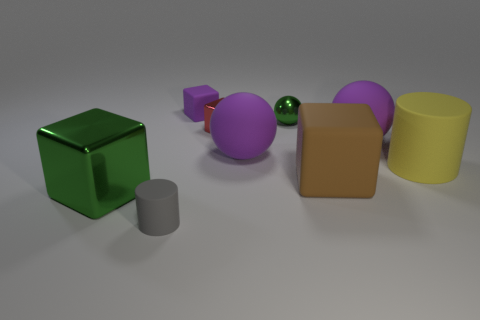What is the material of the block that is the same color as the tiny metal sphere?
Provide a short and direct response. Metal. What is the color of the ball that is the same material as the big green cube?
Give a very brief answer. Green. Are there any other things that are the same size as the shiny ball?
Your answer should be compact. Yes. Does the matte cylinder that is left of the brown rubber block have the same color as the large block behind the green block?
Your answer should be compact. No. Is the number of rubber blocks that are on the right side of the gray object greater than the number of matte blocks to the right of the large matte cylinder?
Your answer should be compact. Yes. There is another tiny object that is the same shape as the small purple rubber object; what is its color?
Provide a short and direct response. Red. Is there anything else that is the same shape as the tiny purple thing?
Your answer should be very brief. Yes. There is a gray rubber object; does it have the same shape as the yellow thing that is in front of the purple block?
Provide a short and direct response. Yes. How many other things are there of the same material as the gray object?
Your answer should be compact. 5. Does the small metallic cube have the same color as the cylinder to the right of the purple matte block?
Provide a short and direct response. No. 